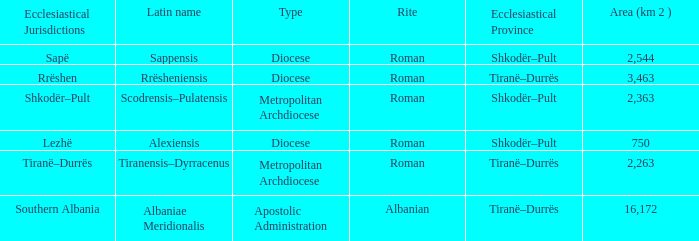What Area (km 2) is lowest with a type being Apostolic Administration? 16172.0. 